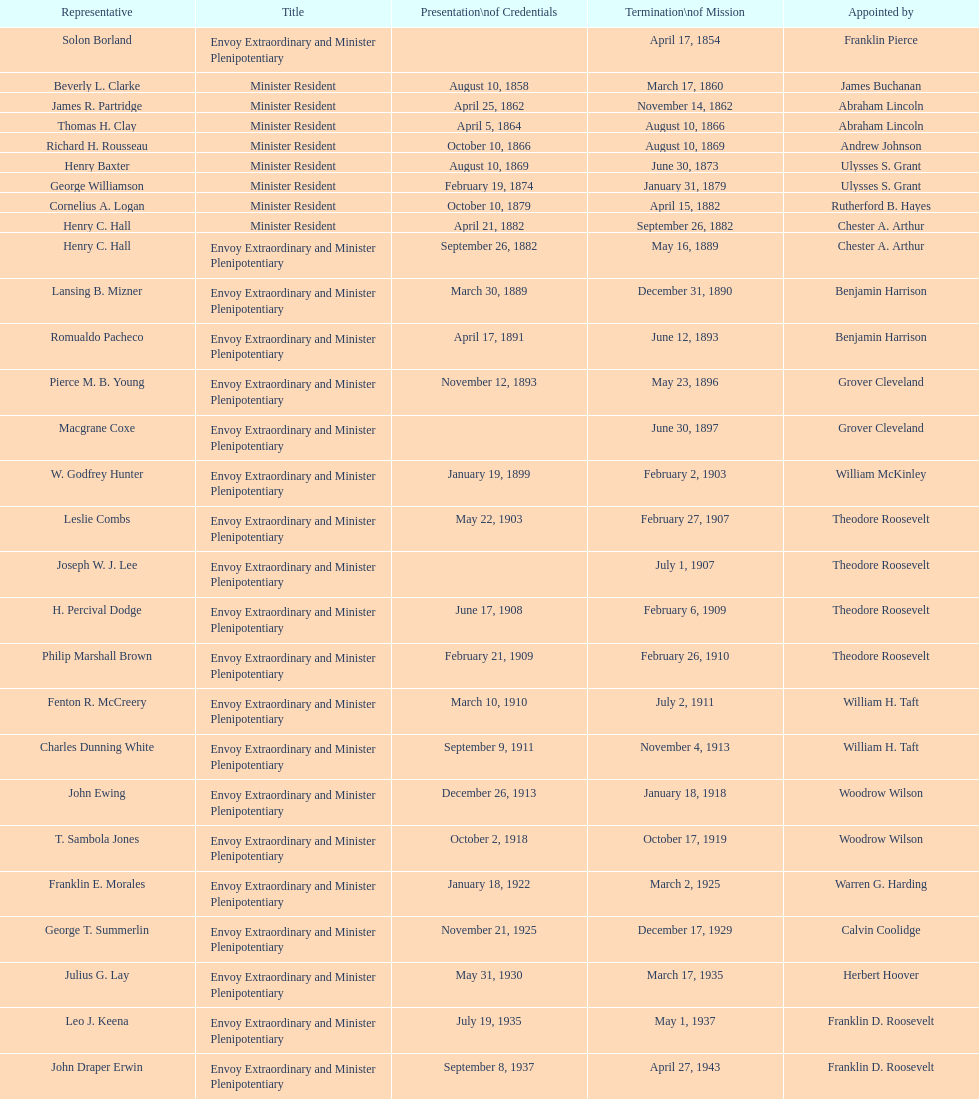Which minister resident experienced the briefest tenure? Henry C. Hall. Could you help me parse every detail presented in this table? {'header': ['Representative', 'Title', 'Presentation\\nof Credentials', 'Termination\\nof Mission', 'Appointed by'], 'rows': [['Solon Borland', 'Envoy Extraordinary and Minister Plenipotentiary', '', 'April 17, 1854', 'Franklin Pierce'], ['Beverly L. Clarke', 'Minister Resident', 'August 10, 1858', 'March 17, 1860', 'James Buchanan'], ['James R. Partridge', 'Minister Resident', 'April 25, 1862', 'November 14, 1862', 'Abraham Lincoln'], ['Thomas H. Clay', 'Minister Resident', 'April 5, 1864', 'August 10, 1866', 'Abraham Lincoln'], ['Richard H. Rousseau', 'Minister Resident', 'October 10, 1866', 'August 10, 1869', 'Andrew Johnson'], ['Henry Baxter', 'Minister Resident', 'August 10, 1869', 'June 30, 1873', 'Ulysses S. Grant'], ['George Williamson', 'Minister Resident', 'February 19, 1874', 'January 31, 1879', 'Ulysses S. Grant'], ['Cornelius A. Logan', 'Minister Resident', 'October 10, 1879', 'April 15, 1882', 'Rutherford B. Hayes'], ['Henry C. Hall', 'Minister Resident', 'April 21, 1882', 'September 26, 1882', 'Chester A. Arthur'], ['Henry C. Hall', 'Envoy Extraordinary and Minister Plenipotentiary', 'September 26, 1882', 'May 16, 1889', 'Chester A. Arthur'], ['Lansing B. Mizner', 'Envoy Extraordinary and Minister Plenipotentiary', 'March 30, 1889', 'December 31, 1890', 'Benjamin Harrison'], ['Romualdo Pacheco', 'Envoy Extraordinary and Minister Plenipotentiary', 'April 17, 1891', 'June 12, 1893', 'Benjamin Harrison'], ['Pierce M. B. Young', 'Envoy Extraordinary and Minister Plenipotentiary', 'November 12, 1893', 'May 23, 1896', 'Grover Cleveland'], ['Macgrane Coxe', 'Envoy Extraordinary and Minister Plenipotentiary', '', 'June 30, 1897', 'Grover Cleveland'], ['W. Godfrey Hunter', 'Envoy Extraordinary and Minister Plenipotentiary', 'January 19, 1899', 'February 2, 1903', 'William McKinley'], ['Leslie Combs', 'Envoy Extraordinary and Minister Plenipotentiary', 'May 22, 1903', 'February 27, 1907', 'Theodore Roosevelt'], ['Joseph W. J. Lee', 'Envoy Extraordinary and Minister Plenipotentiary', '', 'July 1, 1907', 'Theodore Roosevelt'], ['H. Percival Dodge', 'Envoy Extraordinary and Minister Plenipotentiary', 'June 17, 1908', 'February 6, 1909', 'Theodore Roosevelt'], ['Philip Marshall Brown', 'Envoy Extraordinary and Minister Plenipotentiary', 'February 21, 1909', 'February 26, 1910', 'Theodore Roosevelt'], ['Fenton R. McCreery', 'Envoy Extraordinary and Minister Plenipotentiary', 'March 10, 1910', 'July 2, 1911', 'William H. Taft'], ['Charles Dunning White', 'Envoy Extraordinary and Minister Plenipotentiary', 'September 9, 1911', 'November 4, 1913', 'William H. Taft'], ['John Ewing', 'Envoy Extraordinary and Minister Plenipotentiary', 'December 26, 1913', 'January 18, 1918', 'Woodrow Wilson'], ['T. Sambola Jones', 'Envoy Extraordinary and Minister Plenipotentiary', 'October 2, 1918', 'October 17, 1919', 'Woodrow Wilson'], ['Franklin E. Morales', 'Envoy Extraordinary and Minister Plenipotentiary', 'January 18, 1922', 'March 2, 1925', 'Warren G. Harding'], ['George T. Summerlin', 'Envoy Extraordinary and Minister Plenipotentiary', 'November 21, 1925', 'December 17, 1929', 'Calvin Coolidge'], ['Julius G. Lay', 'Envoy Extraordinary and Minister Plenipotentiary', 'May 31, 1930', 'March 17, 1935', 'Herbert Hoover'], ['Leo J. Keena', 'Envoy Extraordinary and Minister Plenipotentiary', 'July 19, 1935', 'May 1, 1937', 'Franklin D. Roosevelt'], ['John Draper Erwin', 'Envoy Extraordinary and Minister Plenipotentiary', 'September 8, 1937', 'April 27, 1943', 'Franklin D. Roosevelt'], ['John Draper Erwin', 'Ambassador Extraordinary and Plenipotentiary', 'April 27, 1943', 'April 16, 1947', 'Franklin D. Roosevelt'], ['Paul C. Daniels', 'Ambassador Extraordinary and Plenipotentiary', 'June 23, 1947', 'October 30, 1947', 'Harry S. Truman'], ['Herbert S. Bursley', 'Ambassador Extraordinary and Plenipotentiary', 'May 15, 1948', 'December 12, 1950', 'Harry S. Truman'], ['John Draper Erwin', 'Ambassador Extraordinary and Plenipotentiary', 'March 14, 1951', 'February 28, 1954', 'Harry S. Truman'], ['Whiting Willauer', 'Ambassador Extraordinary and Plenipotentiary', 'March 5, 1954', 'March 24, 1958', 'Dwight D. Eisenhower'], ['Robert Newbegin', 'Ambassador Extraordinary and Plenipotentiary', 'April 30, 1958', 'August 3, 1960', 'Dwight D. Eisenhower'], ['Charles R. Burrows', 'Ambassador Extraordinary and Plenipotentiary', 'November 3, 1960', 'June 28, 1965', 'Dwight D. Eisenhower'], ['Joseph J. Jova', 'Ambassador Extraordinary and Plenipotentiary', 'July 12, 1965', 'June 21, 1969', 'Lyndon B. Johnson'], ['Hewson A. Ryan', 'Ambassador Extraordinary and Plenipotentiary', 'November 5, 1969', 'May 30, 1973', 'Richard Nixon'], ['Phillip V. Sanchez', 'Ambassador Extraordinary and Plenipotentiary', 'June 15, 1973', 'July 17, 1976', 'Richard Nixon'], ['Ralph E. Becker', 'Ambassador Extraordinary and Plenipotentiary', 'October 27, 1976', 'August 1, 1977', 'Gerald Ford'], ['Mari-Luci Jaramillo', 'Ambassador Extraordinary and Plenipotentiary', 'October 27, 1977', 'September 19, 1980', 'Jimmy Carter'], ['Jack R. Binns', 'Ambassador Extraordinary and Plenipotentiary', 'October 10, 1980', 'October 31, 1981', 'Jimmy Carter'], ['John D. Negroponte', 'Ambassador Extraordinary and Plenipotentiary', 'November 11, 1981', 'May 30, 1985', 'Ronald Reagan'], ['John Arthur Ferch', 'Ambassador Extraordinary and Plenipotentiary', 'August 22, 1985', 'July 9, 1986', 'Ronald Reagan'], ['Everett Ellis Briggs', 'Ambassador Extraordinary and Plenipotentiary', 'November 4, 1986', 'June 15, 1989', 'Ronald Reagan'], ['Cresencio S. Arcos, Jr.', 'Ambassador Extraordinary and Plenipotentiary', 'January 29, 1990', 'July 1, 1993', 'George H. W. Bush'], ['William Thornton Pryce', 'Ambassador Extraordinary and Plenipotentiary', 'July 21, 1993', 'August 15, 1996', 'Bill Clinton'], ['James F. Creagan', 'Ambassador Extraordinary and Plenipotentiary', 'August 29, 1996', 'July 20, 1999', 'Bill Clinton'], ['Frank Almaguer', 'Ambassador Extraordinary and Plenipotentiary', 'August 25, 1999', 'September 5, 2002', 'Bill Clinton'], ['Larry Leon Palmer', 'Ambassador Extraordinary and Plenipotentiary', 'October 8, 2002', 'May 7, 2005', 'George W. Bush'], ['Charles A. Ford', 'Ambassador Extraordinary and Plenipotentiary', 'November 8, 2005', 'ca. April 2008', 'George W. Bush'], ['Hugo Llorens', 'Ambassador Extraordinary and Plenipotentiary', 'September 19, 2008', 'ca. July 2011', 'George W. Bush'], ['Lisa Kubiske', 'Ambassador Extraordinary and Plenipotentiary', 'July 26, 2011', 'Incumbent', 'Barack Obama']]} 